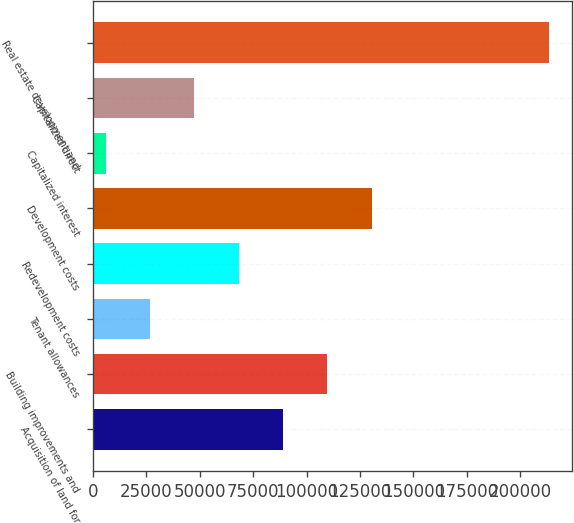Convert chart to OTSL. <chart><loc_0><loc_0><loc_500><loc_500><bar_chart><fcel>Acquisition of land for<fcel>Building improvements and<fcel>Tenant allowances<fcel>Redevelopment costs<fcel>Development costs<fcel>Capitalized interest<fcel>Capitalized direct<fcel>Real estate development and<nl><fcel>88959.6<fcel>109680<fcel>26798.4<fcel>68239.2<fcel>130400<fcel>6078<fcel>47518.8<fcel>213282<nl></chart> 